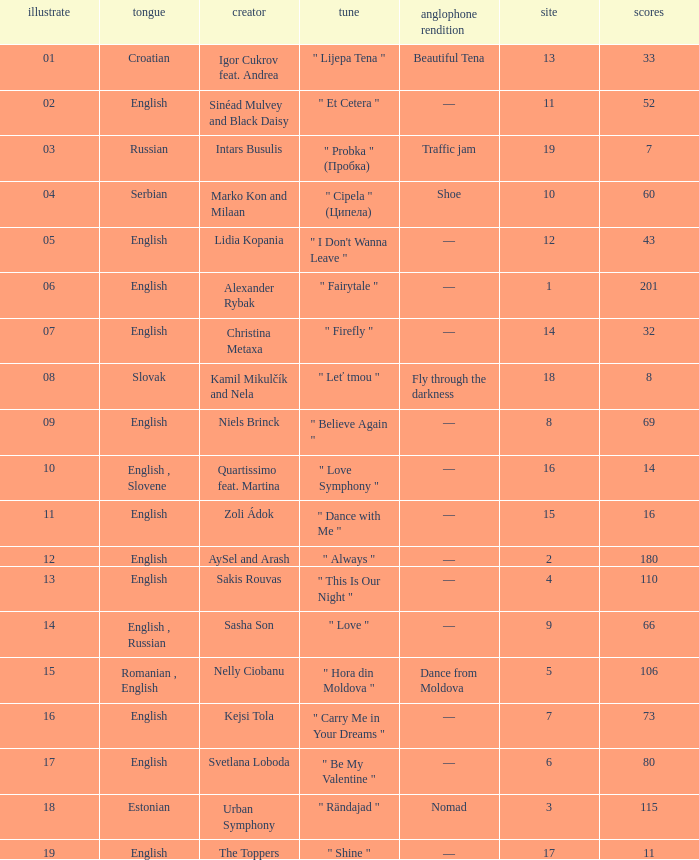Write the full table. {'header': ['illustrate', 'tongue', 'creator', 'tune', 'anglophone rendition', 'site', 'scores'], 'rows': [['01', 'Croatian', 'Igor Cukrov feat. Andrea', '" Lijepa Tena "', 'Beautiful Tena', '13', '33'], ['02', 'English', 'Sinéad Mulvey and Black Daisy', '" Et Cetera "', '—', '11', '52'], ['03', 'Russian', 'Intars Busulis', '" Probka " (Пробка)', 'Traffic jam', '19', '7'], ['04', 'Serbian', 'Marko Kon and Milaan', '" Cipela " (Ципела)', 'Shoe', '10', '60'], ['05', 'English', 'Lidia Kopania', '" I Don\'t Wanna Leave "', '—', '12', '43'], ['06', 'English', 'Alexander Rybak', '" Fairytale "', '—', '1', '201'], ['07', 'English', 'Christina Metaxa', '" Firefly "', '—', '14', '32'], ['08', 'Slovak', 'Kamil Mikulčík and Nela', '" Leť tmou "', 'Fly through the darkness', '18', '8'], ['09', 'English', 'Niels Brinck', '" Believe Again "', '—', '8', '69'], ['10', 'English , Slovene', 'Quartissimo feat. Martina', '" Love Symphony "', '—', '16', '14'], ['11', 'English', 'Zoli Ádok', '" Dance with Me "', '—', '15', '16'], ['12', 'English', 'AySel and Arash', '" Always "', '—', '2', '180'], ['13', 'English', 'Sakis Rouvas', '" This Is Our Night "', '—', '4', '110'], ['14', 'English , Russian', 'Sasha Son', '" Love "', '—', '9', '66'], ['15', 'Romanian , English', 'Nelly Ciobanu', '" Hora din Moldova "', 'Dance from Moldova', '5', '106'], ['16', 'English', 'Kejsi Tola', '" Carry Me in Your Dreams "', '—', '7', '73'], ['17', 'English', 'Svetlana Loboda', '" Be My Valentine "', '—', '6', '80'], ['18', 'Estonian', 'Urban Symphony', '" Rändajad "', 'Nomad', '3', '115'], ['19', 'English', 'The Toppers', '" Shine "', '—', '17', '11']]} What is the place when the draw is less than 12 and the artist is quartissimo feat. martina? 16.0. 